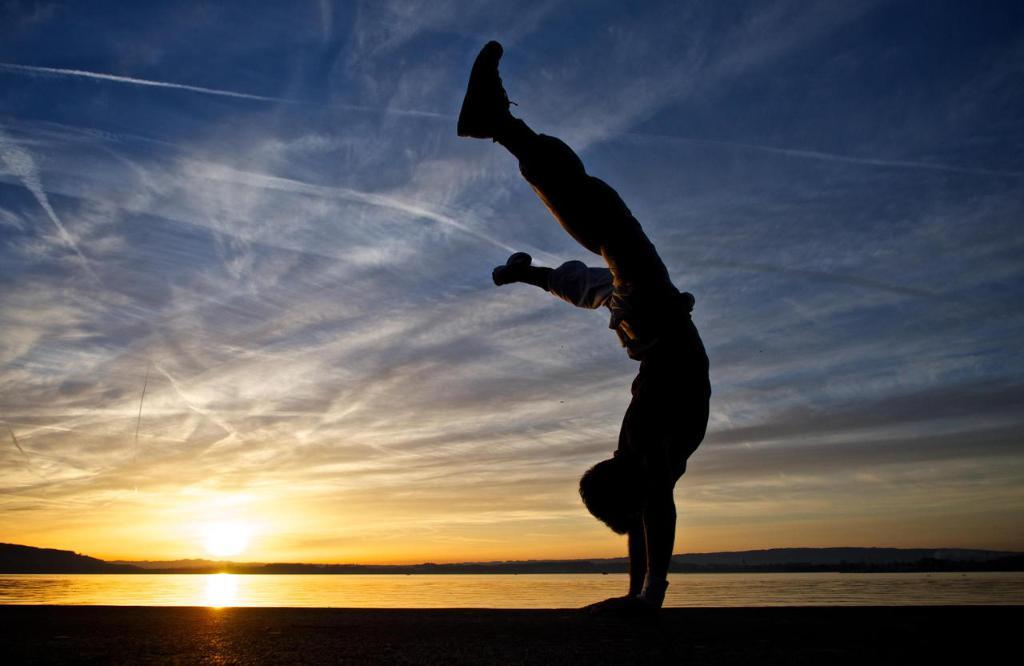What is the main subject of the image? There is a person in the image. How is the person positioned in the image? The person is in a reverse position. What can be seen in the background of the image? There is a sunset visible in the image. What type of cord is being used by the person in the image? There is no cord visible in the image; the person is in a reverse position and no cord is mentioned in the provided facts. 